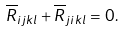<formula> <loc_0><loc_0><loc_500><loc_500>\overline { R } _ { i j k l } + \overline { R } _ { j i k l } = 0 .</formula> 